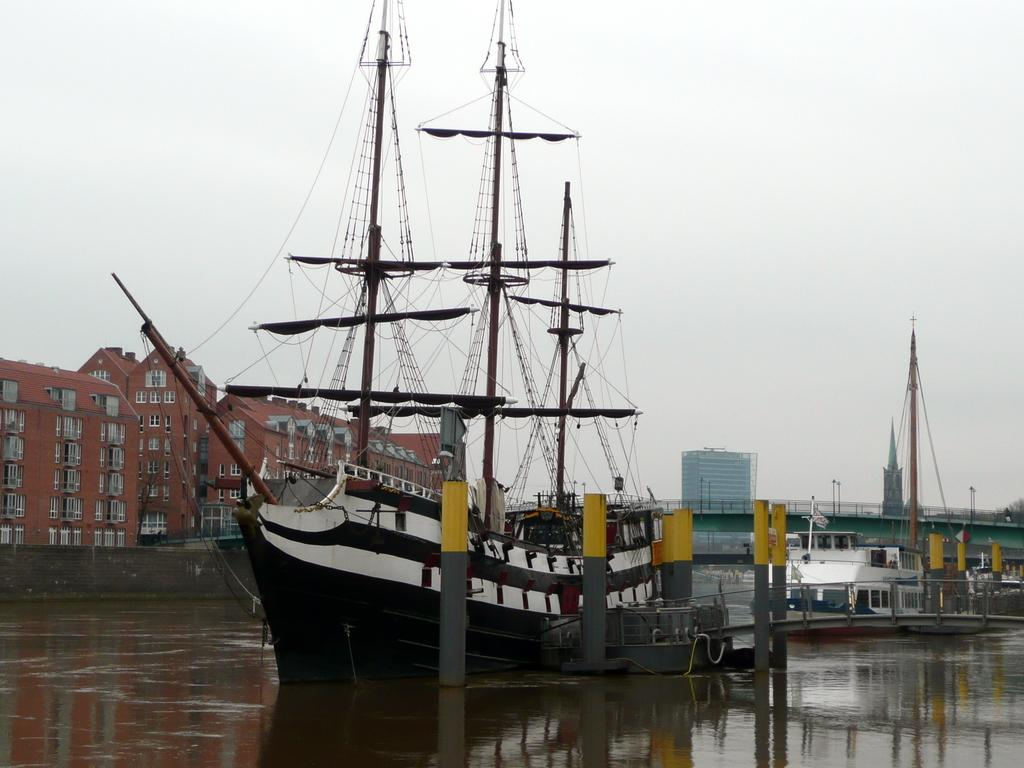What type of vehicles can be seen in the water in the image? There are ships in the water in the image. What structures can be seen in the image besides the ships? There are buildings visible in the image. What part of the natural environment is visible in the image? The sky is visible in the image. What type of rule can be seen on the plate in the image? There is no plate or rule present in the image. What type of drink is being served in the image? There is no drink being served in the image. 